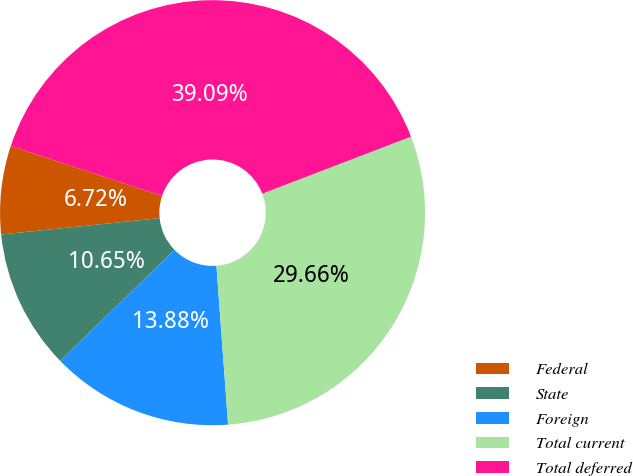<chart> <loc_0><loc_0><loc_500><loc_500><pie_chart><fcel>Federal<fcel>State<fcel>Foreign<fcel>Total current<fcel>Total deferred<nl><fcel>6.72%<fcel>10.65%<fcel>13.88%<fcel>29.66%<fcel>39.09%<nl></chart> 